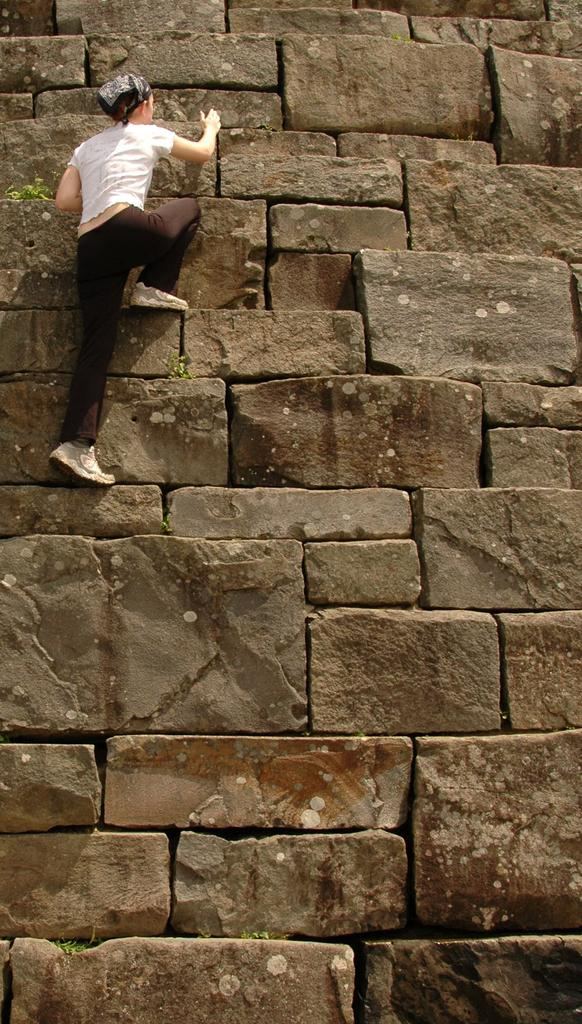What is the main subject of the image? There is a person in the image. What is the person doing in the image? The person is climbing a wall. What type of pin can be seen on the person's shirt in the image? There is no pin visible on the person's shirt in the image. What card game is being played by the person in the image? There is no card game present in the image; the person is climbing a wall. 